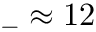<formula> <loc_0><loc_0><loc_500><loc_500>_ { - } \approx 1 2</formula> 